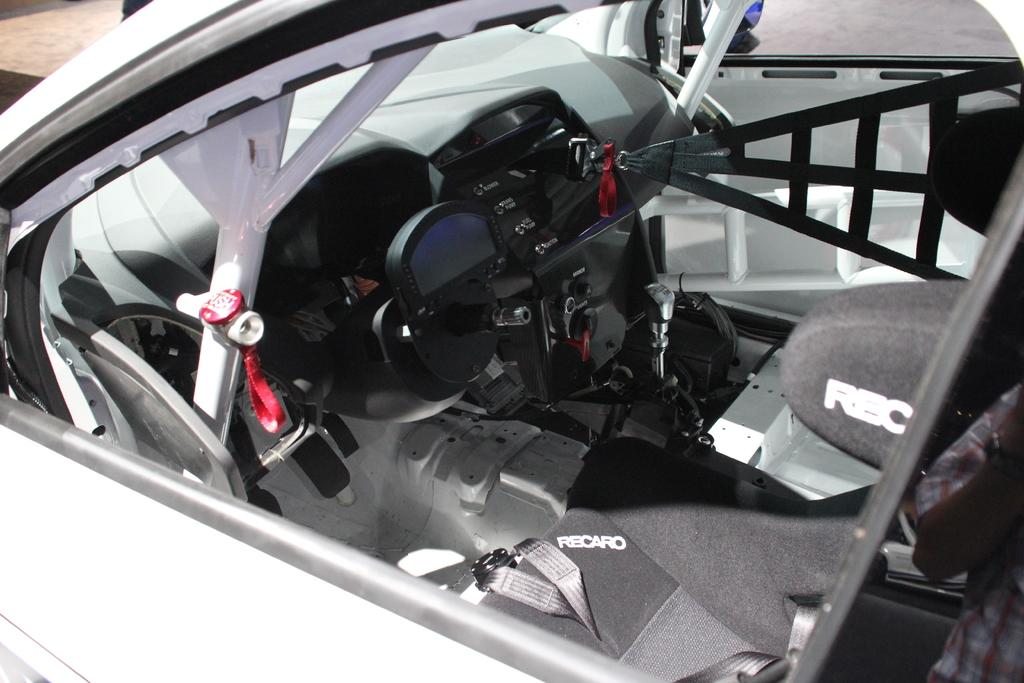What type of space is shown in the image? The image shows the interior of a car. What can be found inside the car? There are seats and seat belts present in the car. Are there any other objects visible in the car? Yes, there are other objects visible in the car. What is the color of the car? The car is white in color. What type of substance is being used to write on the calendar in the image? There is no calendar present in the image, so it is not possible to determine what type of substance might be used to write on it. 